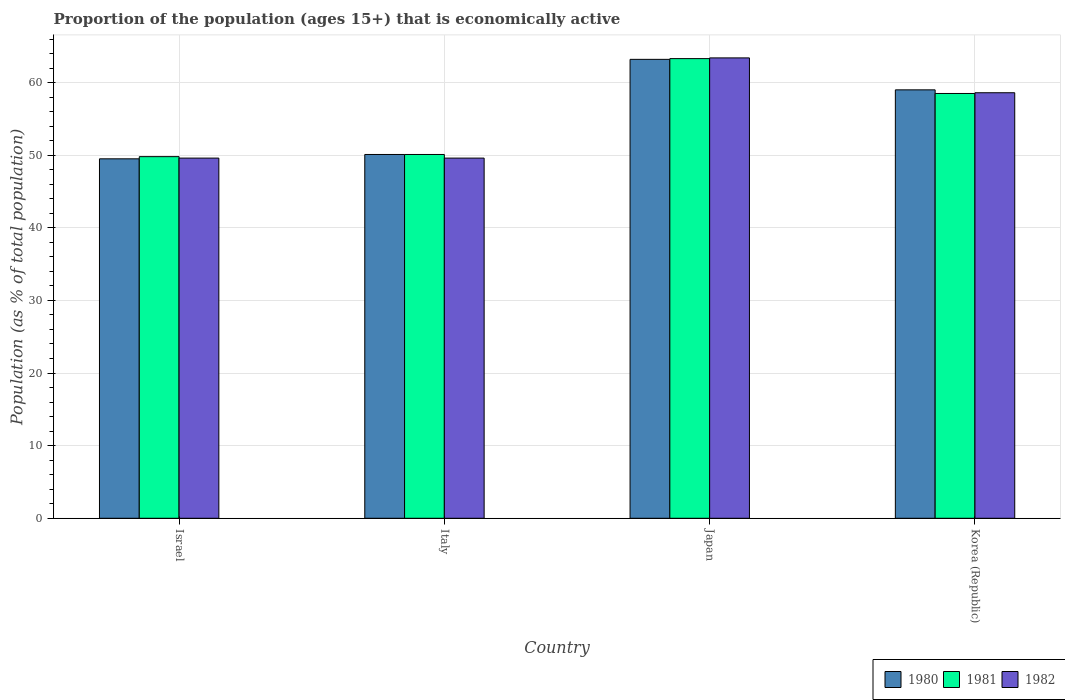How many different coloured bars are there?
Your response must be concise. 3. Are the number of bars per tick equal to the number of legend labels?
Ensure brevity in your answer.  Yes. What is the label of the 4th group of bars from the left?
Ensure brevity in your answer.  Korea (Republic). In how many cases, is the number of bars for a given country not equal to the number of legend labels?
Your answer should be compact. 0. What is the proportion of the population that is economically active in 1981 in Italy?
Your response must be concise. 50.1. Across all countries, what is the maximum proportion of the population that is economically active in 1981?
Offer a terse response. 63.3. Across all countries, what is the minimum proportion of the population that is economically active in 1980?
Your answer should be very brief. 49.5. In which country was the proportion of the population that is economically active in 1981 maximum?
Keep it short and to the point. Japan. What is the total proportion of the population that is economically active in 1980 in the graph?
Make the answer very short. 221.8. What is the difference between the proportion of the population that is economically active in 1980 in Italy and the proportion of the population that is economically active in 1981 in Korea (Republic)?
Give a very brief answer. -8.4. What is the average proportion of the population that is economically active in 1980 per country?
Keep it short and to the point. 55.45. In how many countries, is the proportion of the population that is economically active in 1981 greater than 12 %?
Offer a very short reply. 4. What is the ratio of the proportion of the population that is economically active in 1980 in Israel to that in Italy?
Make the answer very short. 0.99. Is the difference between the proportion of the population that is economically active in 1980 in Israel and Italy greater than the difference between the proportion of the population that is economically active in 1982 in Israel and Italy?
Offer a terse response. No. What is the difference between the highest and the second highest proportion of the population that is economically active in 1980?
Make the answer very short. -8.9. What is the difference between the highest and the lowest proportion of the population that is economically active in 1982?
Your response must be concise. 13.8. Is the sum of the proportion of the population that is economically active in 1981 in Israel and Korea (Republic) greater than the maximum proportion of the population that is economically active in 1982 across all countries?
Offer a terse response. Yes. How are the legend labels stacked?
Offer a very short reply. Horizontal. What is the title of the graph?
Offer a terse response. Proportion of the population (ages 15+) that is economically active. What is the label or title of the X-axis?
Provide a succinct answer. Country. What is the label or title of the Y-axis?
Your answer should be compact. Population (as % of total population). What is the Population (as % of total population) in 1980 in Israel?
Your answer should be very brief. 49.5. What is the Population (as % of total population) of 1981 in Israel?
Your response must be concise. 49.8. What is the Population (as % of total population) of 1982 in Israel?
Ensure brevity in your answer.  49.6. What is the Population (as % of total population) in 1980 in Italy?
Provide a succinct answer. 50.1. What is the Population (as % of total population) of 1981 in Italy?
Make the answer very short. 50.1. What is the Population (as % of total population) in 1982 in Italy?
Your answer should be compact. 49.6. What is the Population (as % of total population) in 1980 in Japan?
Provide a succinct answer. 63.2. What is the Population (as % of total population) in 1981 in Japan?
Your answer should be compact. 63.3. What is the Population (as % of total population) of 1982 in Japan?
Keep it short and to the point. 63.4. What is the Population (as % of total population) in 1981 in Korea (Republic)?
Offer a very short reply. 58.5. What is the Population (as % of total population) of 1982 in Korea (Republic)?
Your answer should be compact. 58.6. Across all countries, what is the maximum Population (as % of total population) in 1980?
Your answer should be compact. 63.2. Across all countries, what is the maximum Population (as % of total population) in 1981?
Keep it short and to the point. 63.3. Across all countries, what is the maximum Population (as % of total population) of 1982?
Your answer should be very brief. 63.4. Across all countries, what is the minimum Population (as % of total population) in 1980?
Your response must be concise. 49.5. Across all countries, what is the minimum Population (as % of total population) of 1981?
Offer a very short reply. 49.8. Across all countries, what is the minimum Population (as % of total population) of 1982?
Keep it short and to the point. 49.6. What is the total Population (as % of total population) in 1980 in the graph?
Your answer should be very brief. 221.8. What is the total Population (as % of total population) of 1981 in the graph?
Keep it short and to the point. 221.7. What is the total Population (as % of total population) of 1982 in the graph?
Offer a terse response. 221.2. What is the difference between the Population (as % of total population) in 1981 in Israel and that in Italy?
Ensure brevity in your answer.  -0.3. What is the difference between the Population (as % of total population) in 1980 in Israel and that in Japan?
Offer a very short reply. -13.7. What is the difference between the Population (as % of total population) of 1982 in Israel and that in Japan?
Give a very brief answer. -13.8. What is the difference between the Population (as % of total population) of 1982 in Israel and that in Korea (Republic)?
Ensure brevity in your answer.  -9. What is the difference between the Population (as % of total population) in 1982 in Italy and that in Japan?
Offer a very short reply. -13.8. What is the difference between the Population (as % of total population) in 1981 in Japan and that in Korea (Republic)?
Ensure brevity in your answer.  4.8. What is the difference between the Population (as % of total population) of 1982 in Japan and that in Korea (Republic)?
Keep it short and to the point. 4.8. What is the difference between the Population (as % of total population) in 1980 in Israel and the Population (as % of total population) in 1981 in Italy?
Provide a succinct answer. -0.6. What is the difference between the Population (as % of total population) in 1981 in Israel and the Population (as % of total population) in 1982 in Italy?
Provide a succinct answer. 0.2. What is the difference between the Population (as % of total population) of 1980 in Israel and the Population (as % of total population) of 1981 in Japan?
Your answer should be very brief. -13.8. What is the difference between the Population (as % of total population) in 1980 in Israel and the Population (as % of total population) in 1981 in Korea (Republic)?
Make the answer very short. -9. What is the difference between the Population (as % of total population) of 1980 in Italy and the Population (as % of total population) of 1981 in Japan?
Give a very brief answer. -13.2. What is the difference between the Population (as % of total population) of 1980 in Italy and the Population (as % of total population) of 1982 in Japan?
Your answer should be compact. -13.3. What is the difference between the Population (as % of total population) in 1981 in Italy and the Population (as % of total population) in 1982 in Japan?
Your answer should be very brief. -13.3. What is the difference between the Population (as % of total population) of 1980 in Italy and the Population (as % of total population) of 1982 in Korea (Republic)?
Ensure brevity in your answer.  -8.5. What is the difference between the Population (as % of total population) in 1981 in Italy and the Population (as % of total population) in 1982 in Korea (Republic)?
Offer a very short reply. -8.5. What is the difference between the Population (as % of total population) in 1980 in Japan and the Population (as % of total population) in 1981 in Korea (Republic)?
Your answer should be compact. 4.7. What is the difference between the Population (as % of total population) in 1980 in Japan and the Population (as % of total population) in 1982 in Korea (Republic)?
Your response must be concise. 4.6. What is the difference between the Population (as % of total population) in 1981 in Japan and the Population (as % of total population) in 1982 in Korea (Republic)?
Your answer should be very brief. 4.7. What is the average Population (as % of total population) of 1980 per country?
Make the answer very short. 55.45. What is the average Population (as % of total population) of 1981 per country?
Make the answer very short. 55.42. What is the average Population (as % of total population) in 1982 per country?
Provide a short and direct response. 55.3. What is the difference between the Population (as % of total population) of 1980 and Population (as % of total population) of 1981 in Japan?
Offer a very short reply. -0.1. What is the difference between the Population (as % of total population) in 1980 and Population (as % of total population) in 1982 in Japan?
Ensure brevity in your answer.  -0.2. What is the difference between the Population (as % of total population) of 1981 and Population (as % of total population) of 1982 in Japan?
Your response must be concise. -0.1. What is the difference between the Population (as % of total population) in 1980 and Population (as % of total population) in 1981 in Korea (Republic)?
Your response must be concise. 0.5. What is the difference between the Population (as % of total population) of 1981 and Population (as % of total population) of 1982 in Korea (Republic)?
Make the answer very short. -0.1. What is the ratio of the Population (as % of total population) in 1982 in Israel to that in Italy?
Ensure brevity in your answer.  1. What is the ratio of the Population (as % of total population) in 1980 in Israel to that in Japan?
Offer a very short reply. 0.78. What is the ratio of the Population (as % of total population) of 1981 in Israel to that in Japan?
Keep it short and to the point. 0.79. What is the ratio of the Population (as % of total population) of 1982 in Israel to that in Japan?
Your answer should be very brief. 0.78. What is the ratio of the Population (as % of total population) of 1980 in Israel to that in Korea (Republic)?
Ensure brevity in your answer.  0.84. What is the ratio of the Population (as % of total population) of 1981 in Israel to that in Korea (Republic)?
Offer a very short reply. 0.85. What is the ratio of the Population (as % of total population) of 1982 in Israel to that in Korea (Republic)?
Give a very brief answer. 0.85. What is the ratio of the Population (as % of total population) of 1980 in Italy to that in Japan?
Offer a very short reply. 0.79. What is the ratio of the Population (as % of total population) of 1981 in Italy to that in Japan?
Provide a succinct answer. 0.79. What is the ratio of the Population (as % of total population) in 1982 in Italy to that in Japan?
Keep it short and to the point. 0.78. What is the ratio of the Population (as % of total population) in 1980 in Italy to that in Korea (Republic)?
Give a very brief answer. 0.85. What is the ratio of the Population (as % of total population) of 1981 in Italy to that in Korea (Republic)?
Ensure brevity in your answer.  0.86. What is the ratio of the Population (as % of total population) of 1982 in Italy to that in Korea (Republic)?
Ensure brevity in your answer.  0.85. What is the ratio of the Population (as % of total population) of 1980 in Japan to that in Korea (Republic)?
Make the answer very short. 1.07. What is the ratio of the Population (as % of total population) of 1981 in Japan to that in Korea (Republic)?
Make the answer very short. 1.08. What is the ratio of the Population (as % of total population) in 1982 in Japan to that in Korea (Republic)?
Make the answer very short. 1.08. What is the difference between the highest and the second highest Population (as % of total population) in 1981?
Provide a short and direct response. 4.8. What is the difference between the highest and the lowest Population (as % of total population) of 1980?
Your answer should be very brief. 13.7. What is the difference between the highest and the lowest Population (as % of total population) of 1981?
Provide a succinct answer. 13.5. 